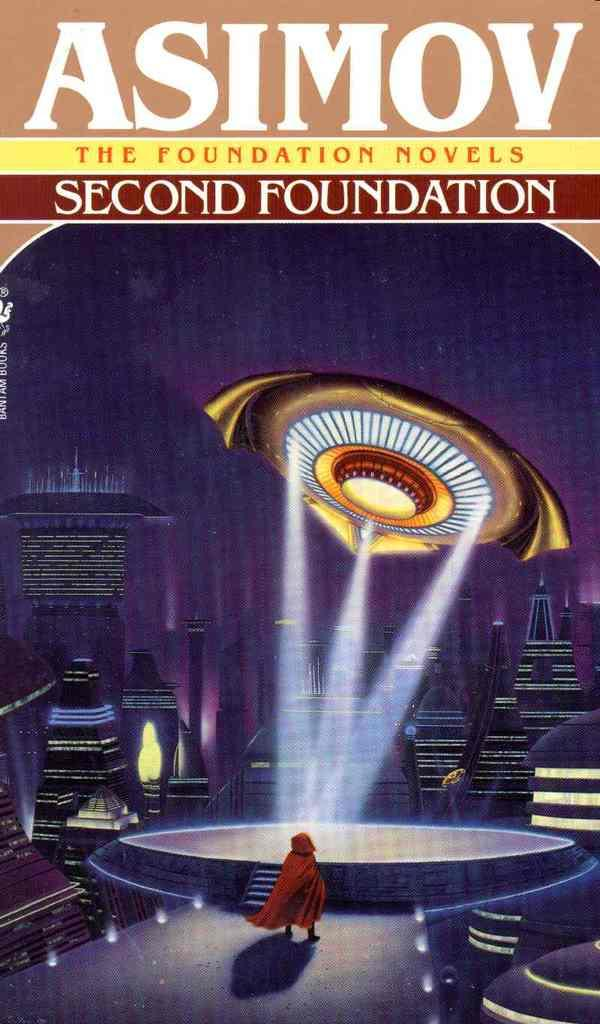What type of image is being described? The image is the cover page of a novel. Can you describe the scene on the cover page? There is a person standing in front of a dais, and there is a spaceship above the person. What color is the brick used to build the spaceship in the image? There is no brick or spaceship being built in the image; it features a person standing in front of a dais with a spaceship above them. 